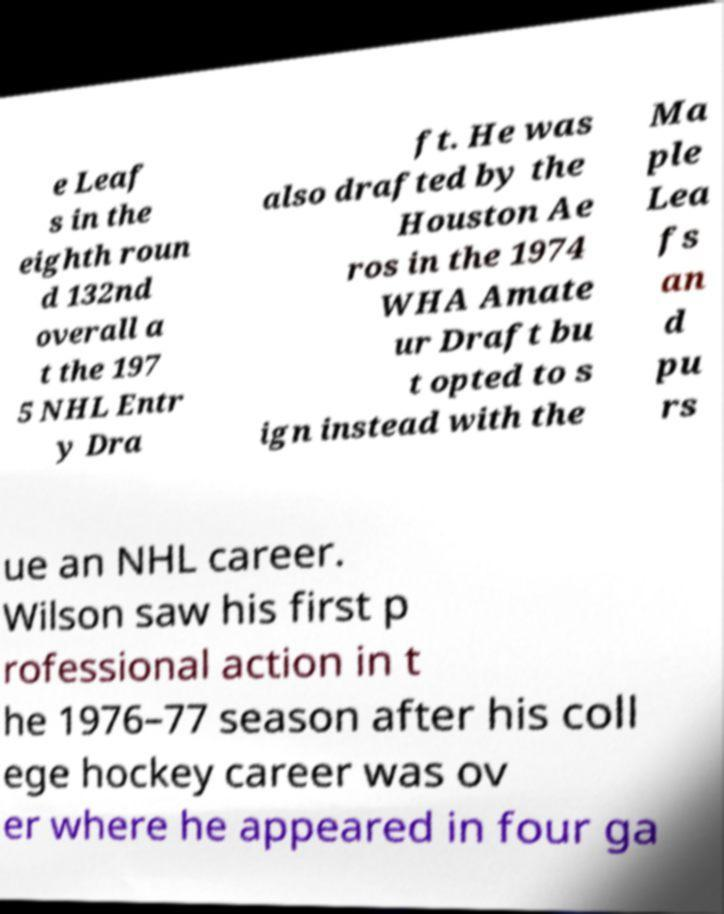I need the written content from this picture converted into text. Can you do that? e Leaf s in the eighth roun d 132nd overall a t the 197 5 NHL Entr y Dra ft. He was also drafted by the Houston Ae ros in the 1974 WHA Amate ur Draft bu t opted to s ign instead with the Ma ple Lea fs an d pu rs ue an NHL career. Wilson saw his first p rofessional action in t he 1976–77 season after his coll ege hockey career was ov er where he appeared in four ga 